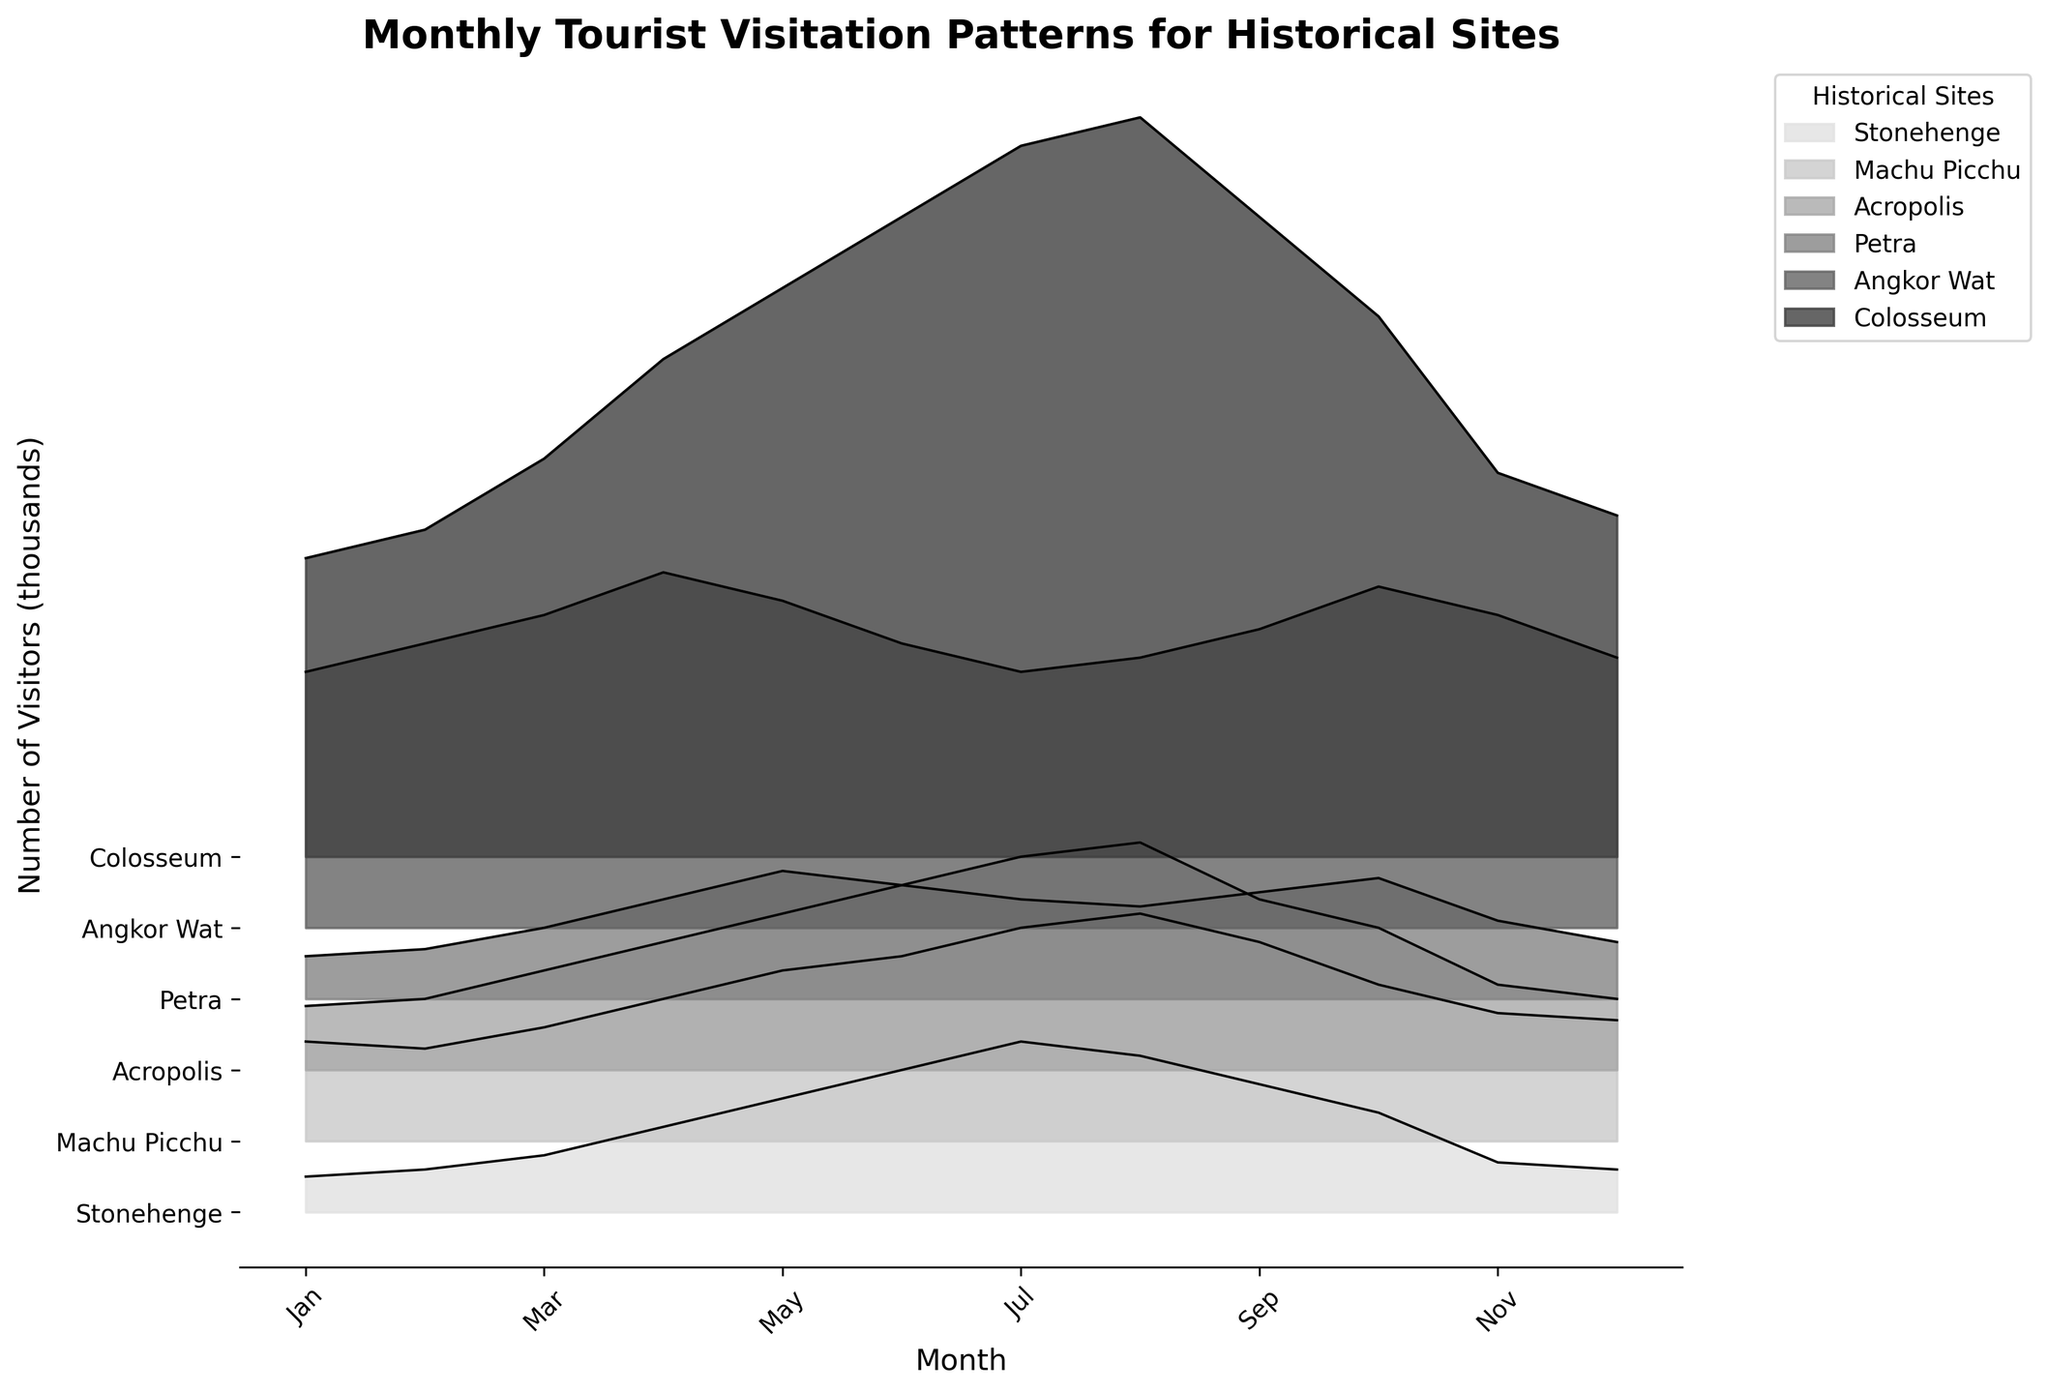What is the title of the figure? The title is usually positioned at the top of the figure and provides an overview of the plot's purpose.
Answer: Monthly Tourist Visitation Patterns for Historical Sites How many historical sites are represented in the plot? Count the number of distinct labels or curves in the plot. Each curve or filled area represents a different historical site.
Answer: 6 Which historical site has the most visitors in July? Locate the data for July on the x-axis and find the curve or fill that reaches the highest point for that month.
Answer: Colosseum What is the difference in visitor numbers between Stonehenge and Petra in April? Find the heights of the curves for Stonehenge and Petra in April, convert these heights back to the original scale (multiply by 1000), then subtract the two values (60000 - 70000). Convert back to thousands.
Answer: -10000 How does the visitation pattern for Machu Picchu compare between January and December? Identify the curves for Machu Picchu in January and December, and compare their heights. Divide each value by 1000 and look at the relative positions in the plot for both months.
Answer: January has more visitors than December Which historical sites experience a peak in visitor numbers in August? Look at all the curves for August and identify which one reaches a high point there.
Answer: Machu Picchu, Acropolis, and Colosseum Which historical site shows the least variation in visitor numbers across the year? Observe the plot and identify the site with the least fluctuation in the height of its curve across the months.
Answer: Angkor Wat In which month does Petra receive more visitors than Stonehenge but fewer than the Colosseum? For each month, compare the curve heights (converted back to the original scale) for Stonehenge, Petra, and Colosseum to identify the required month.
Answer: October What is the average number of visitors (in thousands) to Acropolis over the year? Add up the monthly visitor numbers for Acropolis, then divide by the total number of months (12). Use the heights of the curves to find the monthly visitor numbers and apply the conversion factor.
Answer: 97500 